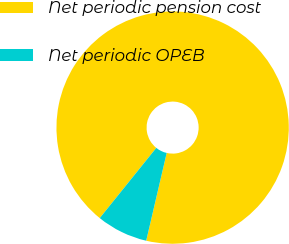Convert chart. <chart><loc_0><loc_0><loc_500><loc_500><pie_chart><fcel>Net periodic pension cost<fcel>Net periodic OPEB<nl><fcel>92.86%<fcel>7.14%<nl></chart> 